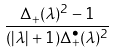Convert formula to latex. <formula><loc_0><loc_0><loc_500><loc_500>\frac { \Delta _ { + } ( \lambda ) ^ { 2 } - 1 } { ( | \lambda | + 1 ) \Delta _ { + } ^ { \bullet } ( \lambda ) ^ { 2 } }</formula> 